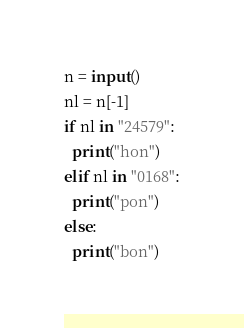<code> <loc_0><loc_0><loc_500><loc_500><_Python_>n = input()
nl = n[-1]
if nl in "24579":
  print("hon")
elif nl in "0168":
  print("pon")
else:
  print("bon")</code> 